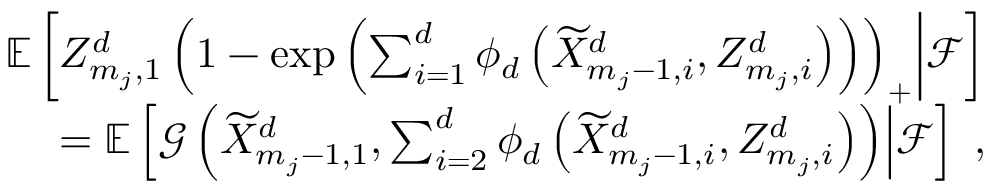<formula> <loc_0><loc_0><loc_500><loc_500>\begin{array} { r } { { \mathbb { E } \left [ Z _ { m _ { j } , 1 } ^ { d } \left ( 1 - \exp \left ( \sum _ { i = 1 } ^ { d } \phi _ { d } \left ( \widetilde { X } _ { m _ { j } - 1 , i } ^ { d } , Z _ { m _ { j } , i } ^ { d } \right ) \right ) \right ) _ { + } | d l e | \mathcal { F } \right ] } } \\ { = { \mathbb { E } \left [ \mathcal { G } \left ( \widetilde { X } _ { m _ { j } - 1 , 1 } ^ { d } , \sum _ { i = 2 } ^ { d } \phi _ { d } \left ( \widetilde { X } _ { m _ { j } - 1 , i } ^ { d } , Z _ { m _ { j } , i } ^ { d } \right ) \right ) | d l e | \mathcal { F } \right ] } \, , } \end{array}</formula> 